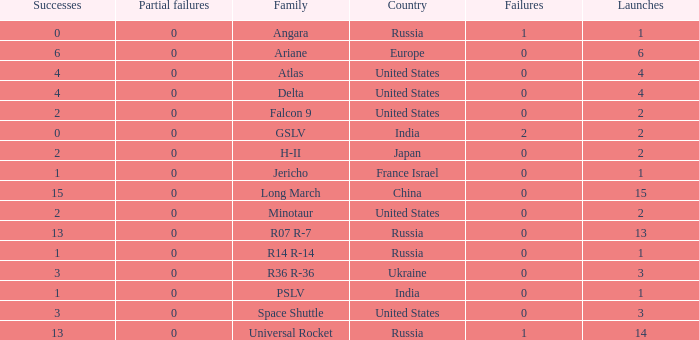What is the number of failure for the country of Russia, and a Family of r14 r-14, and a Partial failures smaller than 0? 0.0. 